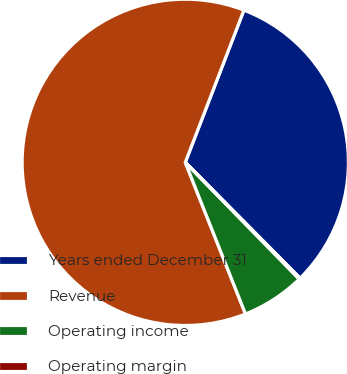Convert chart. <chart><loc_0><loc_0><loc_500><loc_500><pie_chart><fcel>Years ended December 31<fcel>Revenue<fcel>Operating income<fcel>Operating margin<nl><fcel>31.72%<fcel>61.87%<fcel>6.29%<fcel>0.12%<nl></chart> 